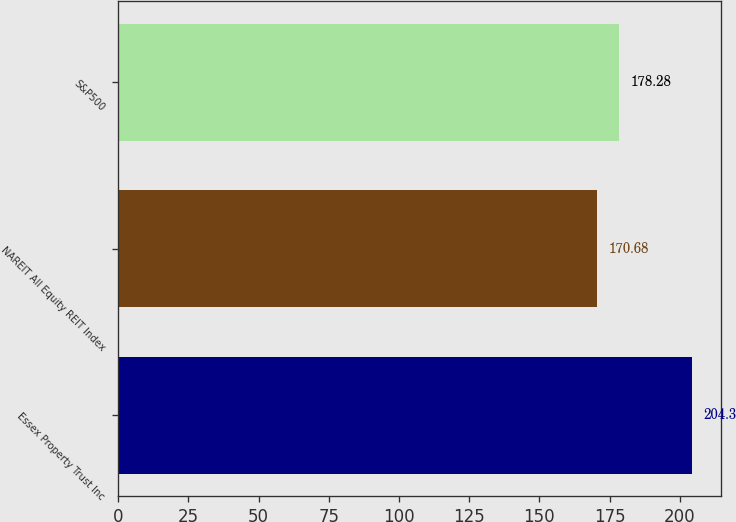<chart> <loc_0><loc_0><loc_500><loc_500><bar_chart><fcel>Essex Property Trust Inc<fcel>NAREIT All Equity REIT Index<fcel>S&P500<nl><fcel>204.3<fcel>170.68<fcel>178.28<nl></chart> 